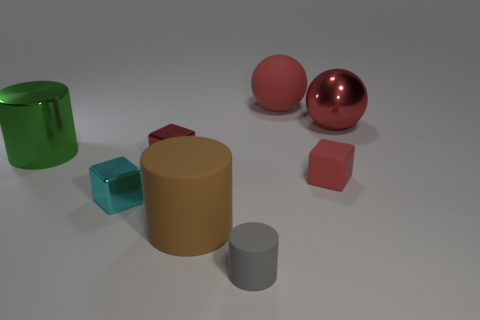Add 1 metallic cylinders. How many objects exist? 9 Subtract all spheres. How many objects are left? 6 Add 5 large brown cylinders. How many large brown cylinders exist? 6 Subtract 0 gray blocks. How many objects are left? 8 Subtract all green objects. Subtract all gray matte cylinders. How many objects are left? 6 Add 1 gray matte things. How many gray matte things are left? 2 